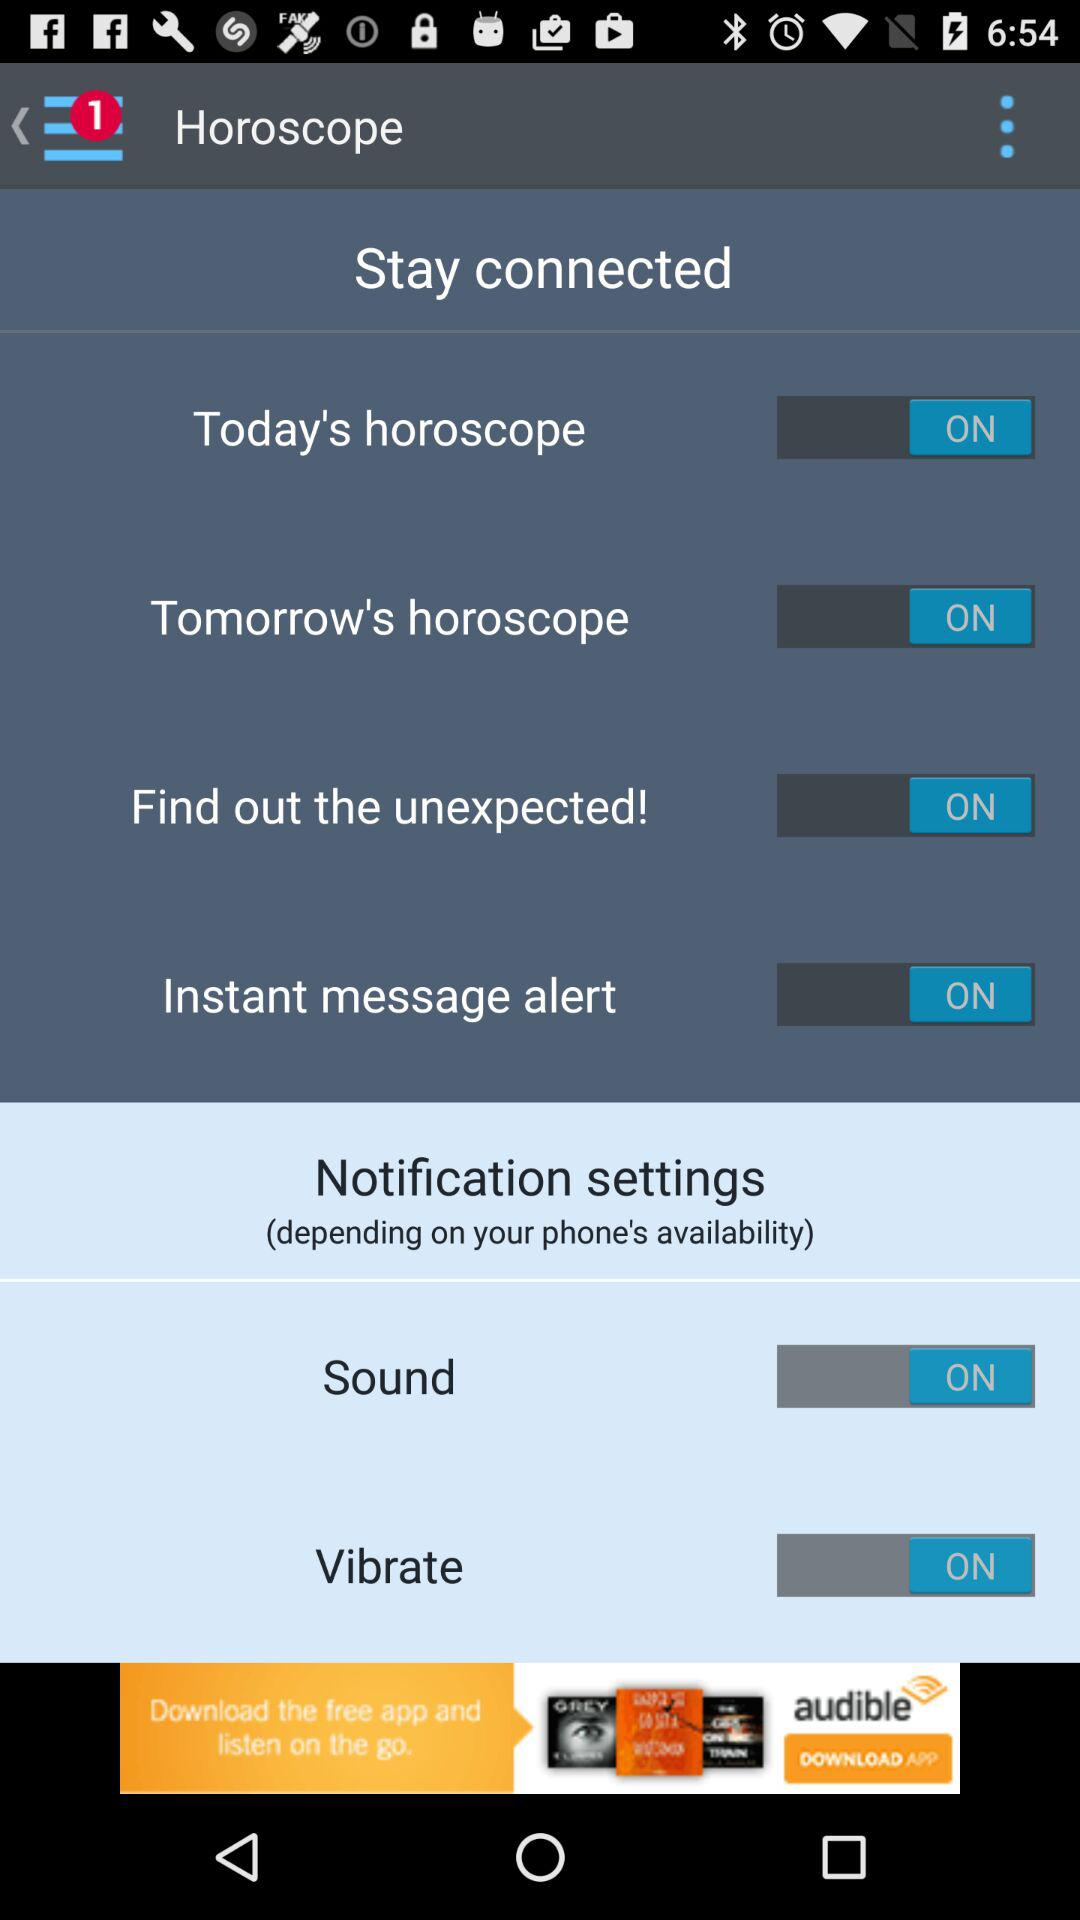What is the status of today's horoscope? The status of today's horoscope is "ON". 